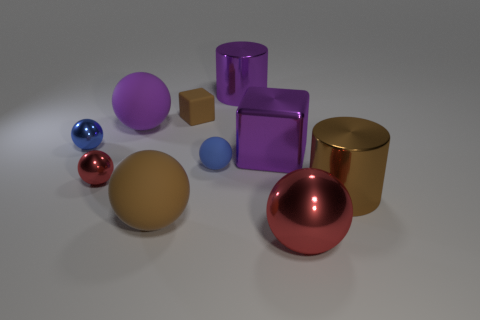What shapes are visible in the image, and can you describe their arrangement? The image features a variety of geometric shapes, including spheres, cylinders, cubes, and a block. They are scattered across the surface in a seemingly random pattern, with no particular order or arrangement. 